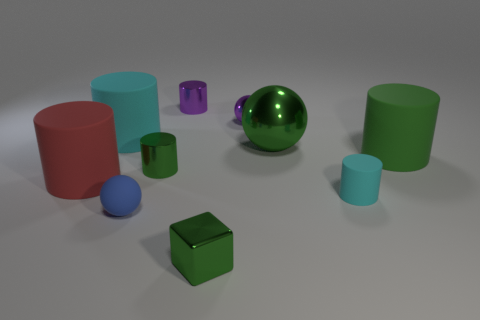Is the number of small shiny spheres that are on the right side of the small purple metallic ball the same as the number of large red shiny cylinders?
Offer a very short reply. Yes. What is the size of the red object?
Ensure brevity in your answer.  Large. What material is the tiny cube that is the same color as the big shiny thing?
Provide a short and direct response. Metal. What number of metallic cylinders have the same color as the big shiny thing?
Offer a very short reply. 1. Do the red cylinder and the green sphere have the same size?
Offer a very short reply. Yes. There is a metallic cylinder that is in front of the large rubber cylinder that is behind the large green cylinder; what is its size?
Your answer should be compact. Small. There is a tiny cube; is its color the same as the big cylinder to the right of the cube?
Provide a succinct answer. Yes. Are there any purple spheres that have the same size as the green metallic block?
Your answer should be compact. Yes. How big is the cyan thing that is to the right of the small purple shiny cylinder?
Give a very brief answer. Small. There is a purple object that is to the left of the tiny green block; are there any purple metal balls behind it?
Offer a terse response. No. 